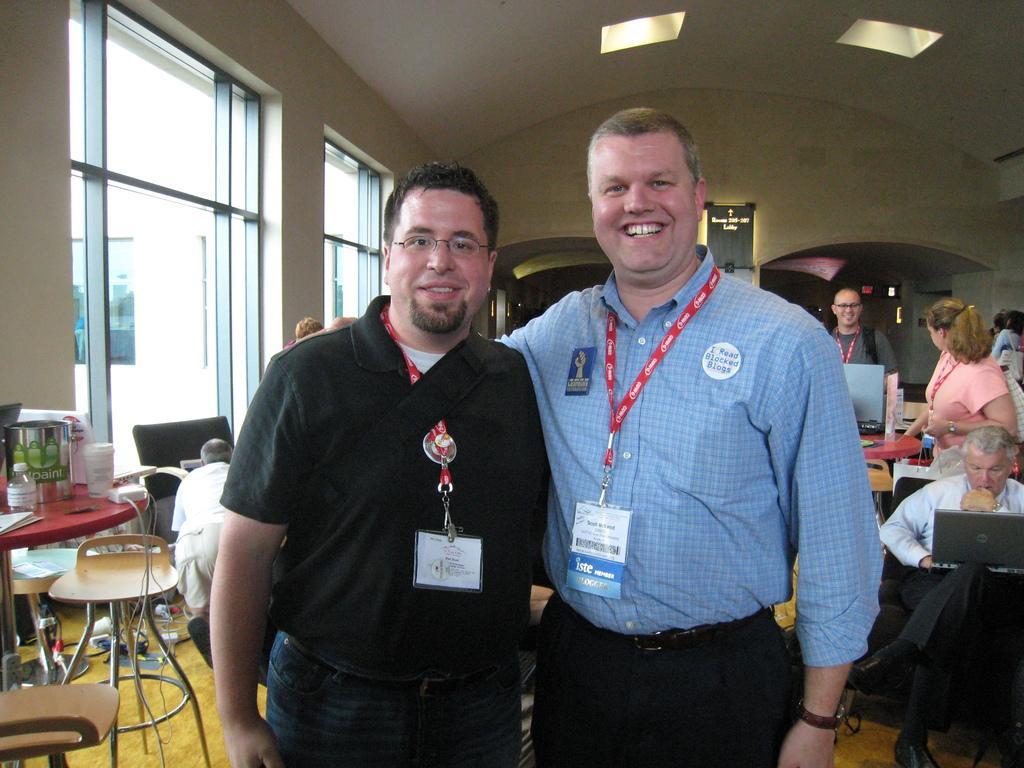Please provide a concise description of this image. This picture shows two men standing with a smile on their faces and they wore a id tag on their necks and we see couple of chairs and a bag on the table and we see a man seated on the chair and working on the laptop and we see a woman and a man standing on his back and we see couple of lights on the roof and a window on the side 